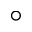Convert formula to latex. <formula><loc_0><loc_0><loc_500><loc_500>^ { \circ }</formula> 